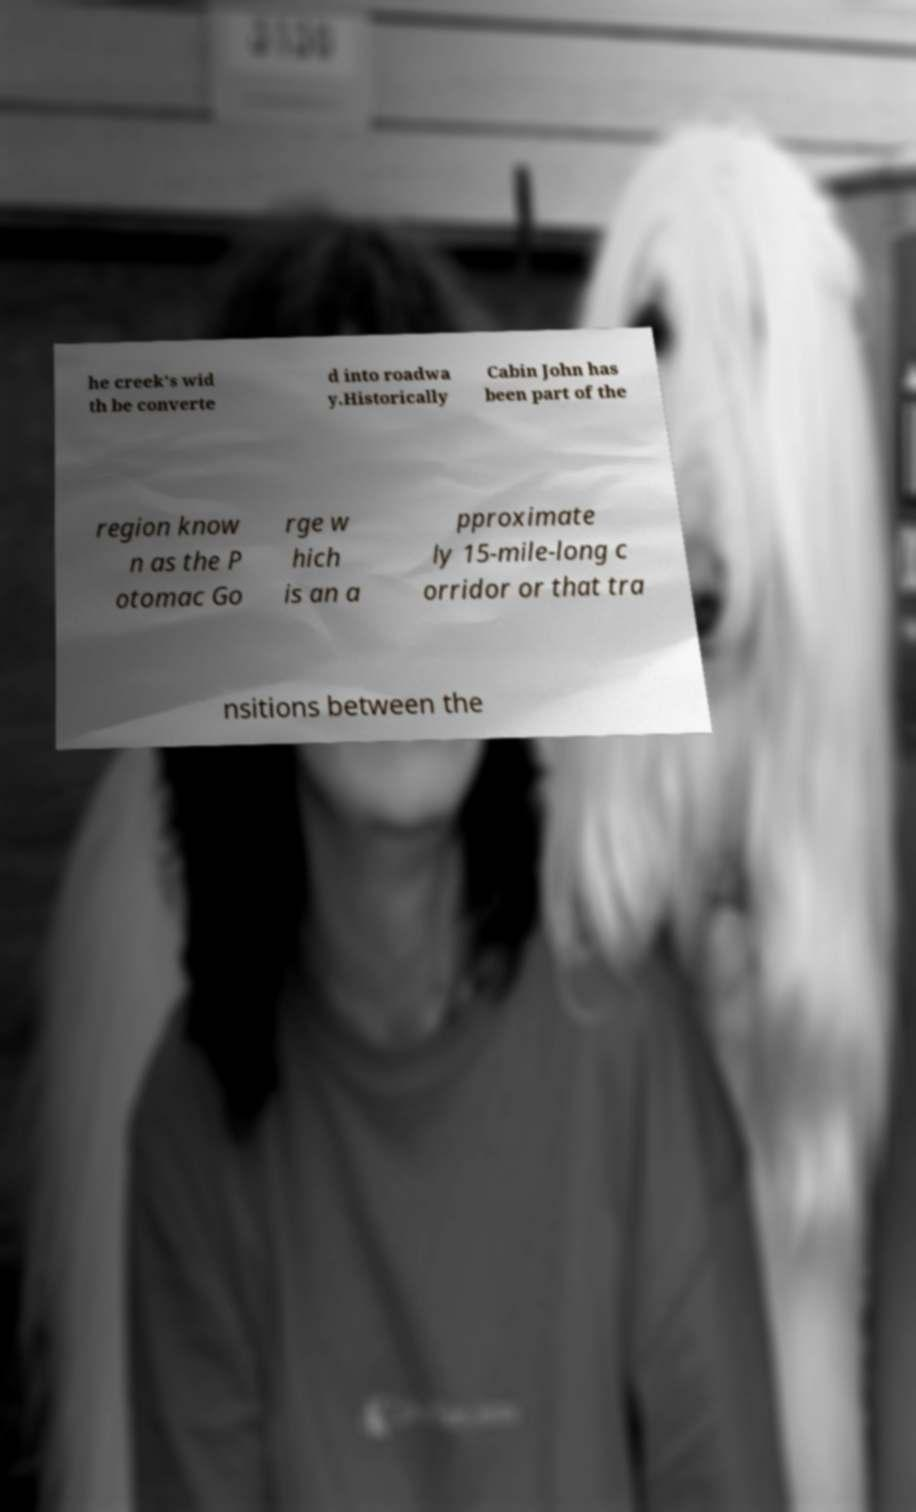Can you read and provide the text displayed in the image?This photo seems to have some interesting text. Can you extract and type it out for me? he creek's wid th be converte d into roadwa y.Historically Cabin John has been part of the region know n as the P otomac Go rge w hich is an a pproximate ly 15-mile-long c orridor or that tra nsitions between the 